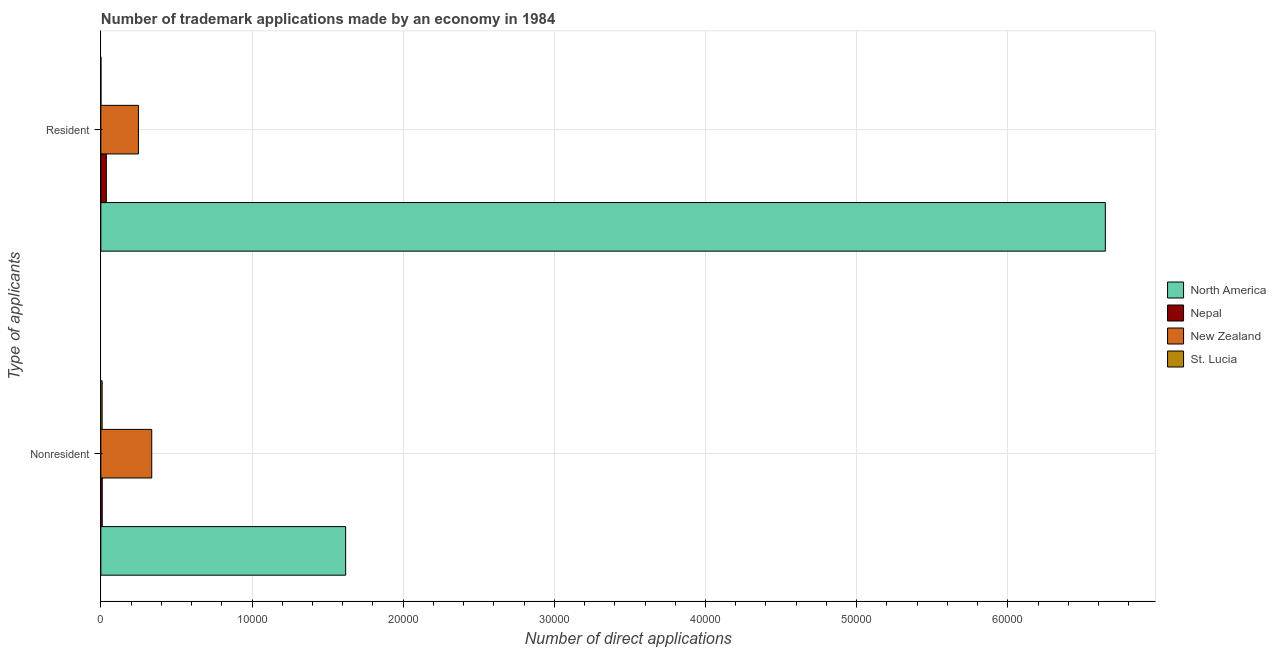How many different coloured bars are there?
Your answer should be compact. 4. What is the label of the 1st group of bars from the top?
Keep it short and to the point. Resident. What is the number of trademark applications made by residents in Nepal?
Offer a very short reply. 365. Across all countries, what is the maximum number of trademark applications made by residents?
Provide a succinct answer. 6.64e+04. Across all countries, what is the minimum number of trademark applications made by residents?
Keep it short and to the point. 3. In which country was the number of trademark applications made by residents minimum?
Your response must be concise. St. Lucia. What is the total number of trademark applications made by non residents in the graph?
Provide a succinct answer. 1.97e+04. What is the difference between the number of trademark applications made by non residents in Nepal and that in North America?
Your response must be concise. -1.61e+04. What is the difference between the number of trademark applications made by non residents in North America and the number of trademark applications made by residents in New Zealand?
Your response must be concise. 1.37e+04. What is the average number of trademark applications made by residents per country?
Ensure brevity in your answer.  1.73e+04. What is the difference between the number of trademark applications made by non residents and number of trademark applications made by residents in Nepal?
Your response must be concise. -273. In how many countries, is the number of trademark applications made by non residents greater than 12000 ?
Your answer should be very brief. 1. What is the ratio of the number of trademark applications made by residents in Nepal to that in St. Lucia?
Keep it short and to the point. 121.67. Is the number of trademark applications made by residents in Nepal less than that in St. Lucia?
Your answer should be very brief. No. In how many countries, is the number of trademark applications made by residents greater than the average number of trademark applications made by residents taken over all countries?
Offer a terse response. 1. How many bars are there?
Your response must be concise. 8. What is the difference between two consecutive major ticks on the X-axis?
Give a very brief answer. 10000. Are the values on the major ticks of X-axis written in scientific E-notation?
Provide a succinct answer. No. Does the graph contain grids?
Offer a very short reply. Yes. How many legend labels are there?
Your answer should be compact. 4. What is the title of the graph?
Keep it short and to the point. Number of trademark applications made by an economy in 1984. What is the label or title of the X-axis?
Your response must be concise. Number of direct applications. What is the label or title of the Y-axis?
Offer a terse response. Type of applicants. What is the Number of direct applications in North America in Nonresident?
Make the answer very short. 1.62e+04. What is the Number of direct applications in Nepal in Nonresident?
Give a very brief answer. 92. What is the Number of direct applications in New Zealand in Nonresident?
Your answer should be very brief. 3368. What is the Number of direct applications in North America in Resident?
Offer a terse response. 6.64e+04. What is the Number of direct applications in Nepal in Resident?
Make the answer very short. 365. What is the Number of direct applications of New Zealand in Resident?
Provide a short and direct response. 2487. What is the Number of direct applications of St. Lucia in Resident?
Offer a terse response. 3. Across all Type of applicants, what is the maximum Number of direct applications of North America?
Offer a terse response. 6.64e+04. Across all Type of applicants, what is the maximum Number of direct applications in Nepal?
Offer a terse response. 365. Across all Type of applicants, what is the maximum Number of direct applications in New Zealand?
Make the answer very short. 3368. Across all Type of applicants, what is the minimum Number of direct applications in North America?
Provide a succinct answer. 1.62e+04. Across all Type of applicants, what is the minimum Number of direct applications of Nepal?
Give a very brief answer. 92. Across all Type of applicants, what is the minimum Number of direct applications in New Zealand?
Give a very brief answer. 2487. Across all Type of applicants, what is the minimum Number of direct applications in St. Lucia?
Ensure brevity in your answer.  3. What is the total Number of direct applications of North America in the graph?
Give a very brief answer. 8.26e+04. What is the total Number of direct applications of Nepal in the graph?
Provide a succinct answer. 457. What is the total Number of direct applications of New Zealand in the graph?
Provide a short and direct response. 5855. What is the total Number of direct applications of St. Lucia in the graph?
Your response must be concise. 90. What is the difference between the Number of direct applications of North America in Nonresident and that in Resident?
Offer a terse response. -5.03e+04. What is the difference between the Number of direct applications in Nepal in Nonresident and that in Resident?
Your answer should be very brief. -273. What is the difference between the Number of direct applications in New Zealand in Nonresident and that in Resident?
Provide a short and direct response. 881. What is the difference between the Number of direct applications in St. Lucia in Nonresident and that in Resident?
Give a very brief answer. 84. What is the difference between the Number of direct applications in North America in Nonresident and the Number of direct applications in Nepal in Resident?
Ensure brevity in your answer.  1.58e+04. What is the difference between the Number of direct applications in North America in Nonresident and the Number of direct applications in New Zealand in Resident?
Your answer should be compact. 1.37e+04. What is the difference between the Number of direct applications in North America in Nonresident and the Number of direct applications in St. Lucia in Resident?
Your answer should be very brief. 1.62e+04. What is the difference between the Number of direct applications in Nepal in Nonresident and the Number of direct applications in New Zealand in Resident?
Provide a short and direct response. -2395. What is the difference between the Number of direct applications of Nepal in Nonresident and the Number of direct applications of St. Lucia in Resident?
Offer a very short reply. 89. What is the difference between the Number of direct applications of New Zealand in Nonresident and the Number of direct applications of St. Lucia in Resident?
Provide a short and direct response. 3365. What is the average Number of direct applications of North America per Type of applicants?
Your answer should be compact. 4.13e+04. What is the average Number of direct applications of Nepal per Type of applicants?
Make the answer very short. 228.5. What is the average Number of direct applications of New Zealand per Type of applicants?
Give a very brief answer. 2927.5. What is the average Number of direct applications in St. Lucia per Type of applicants?
Give a very brief answer. 45. What is the difference between the Number of direct applications in North America and Number of direct applications in Nepal in Nonresident?
Provide a succinct answer. 1.61e+04. What is the difference between the Number of direct applications of North America and Number of direct applications of New Zealand in Nonresident?
Ensure brevity in your answer.  1.28e+04. What is the difference between the Number of direct applications of North America and Number of direct applications of St. Lucia in Nonresident?
Offer a terse response. 1.61e+04. What is the difference between the Number of direct applications in Nepal and Number of direct applications in New Zealand in Nonresident?
Ensure brevity in your answer.  -3276. What is the difference between the Number of direct applications in New Zealand and Number of direct applications in St. Lucia in Nonresident?
Your response must be concise. 3281. What is the difference between the Number of direct applications of North America and Number of direct applications of Nepal in Resident?
Offer a terse response. 6.61e+04. What is the difference between the Number of direct applications in North America and Number of direct applications in New Zealand in Resident?
Provide a short and direct response. 6.40e+04. What is the difference between the Number of direct applications of North America and Number of direct applications of St. Lucia in Resident?
Give a very brief answer. 6.64e+04. What is the difference between the Number of direct applications in Nepal and Number of direct applications in New Zealand in Resident?
Offer a very short reply. -2122. What is the difference between the Number of direct applications of Nepal and Number of direct applications of St. Lucia in Resident?
Make the answer very short. 362. What is the difference between the Number of direct applications of New Zealand and Number of direct applications of St. Lucia in Resident?
Give a very brief answer. 2484. What is the ratio of the Number of direct applications of North America in Nonresident to that in Resident?
Your response must be concise. 0.24. What is the ratio of the Number of direct applications of Nepal in Nonresident to that in Resident?
Provide a succinct answer. 0.25. What is the ratio of the Number of direct applications of New Zealand in Nonresident to that in Resident?
Provide a succinct answer. 1.35. What is the difference between the highest and the second highest Number of direct applications of North America?
Give a very brief answer. 5.03e+04. What is the difference between the highest and the second highest Number of direct applications of Nepal?
Offer a terse response. 273. What is the difference between the highest and the second highest Number of direct applications of New Zealand?
Provide a succinct answer. 881. What is the difference between the highest and the lowest Number of direct applications in North America?
Your response must be concise. 5.03e+04. What is the difference between the highest and the lowest Number of direct applications in Nepal?
Give a very brief answer. 273. What is the difference between the highest and the lowest Number of direct applications in New Zealand?
Offer a very short reply. 881. What is the difference between the highest and the lowest Number of direct applications of St. Lucia?
Keep it short and to the point. 84. 